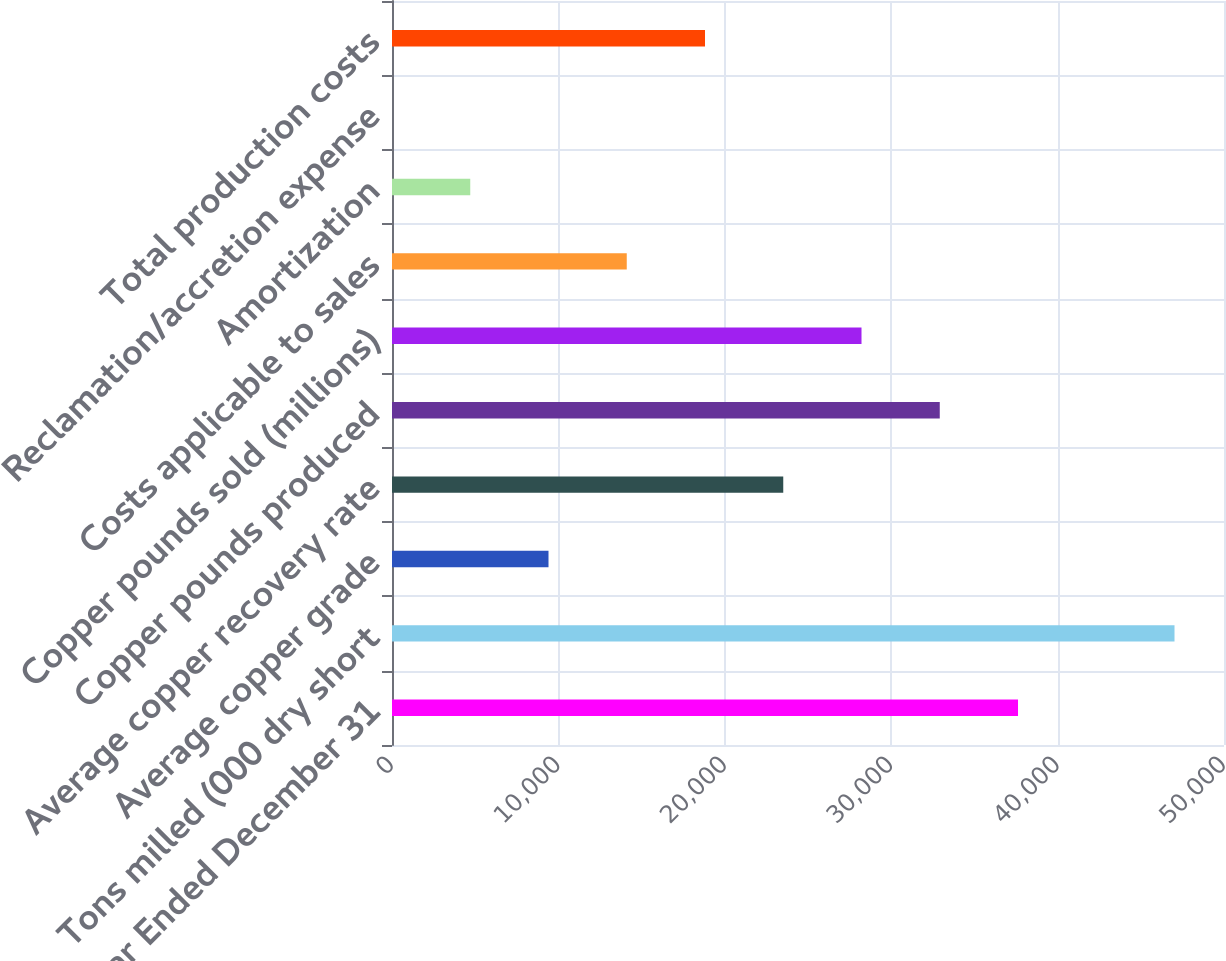Convert chart. <chart><loc_0><loc_0><loc_500><loc_500><bar_chart><fcel>Year Ended December 31<fcel>Tons milled (000 dry short<fcel>Average copper grade<fcel>Average copper recovery rate<fcel>Copper pounds produced<fcel>Copper pounds sold (millions)<fcel>Costs applicable to sales<fcel>Amortization<fcel>Reclamation/accretion expense<fcel>Total production costs<nl><fcel>37620.8<fcel>47026<fcel>9405.21<fcel>23513<fcel>32918.2<fcel>28215.6<fcel>14107.8<fcel>4702.61<fcel>0.01<fcel>18810.4<nl></chart> 